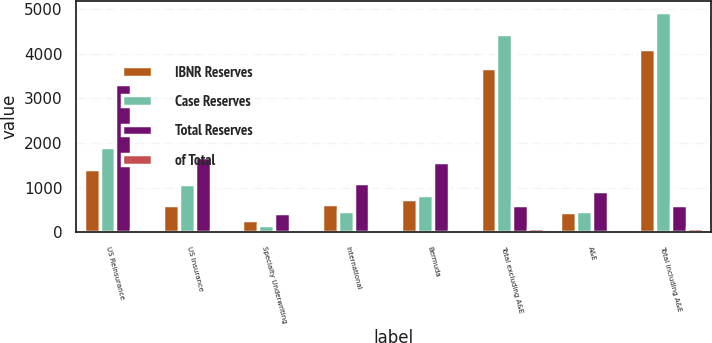Convert chart to OTSL. <chart><loc_0><loc_0><loc_500><loc_500><stacked_bar_chart><ecel><fcel>US Reinsurance<fcel>US Insurance<fcel>Specialty Underwriting<fcel>International<fcel>Bermuda<fcel>Total excluding A&E<fcel>A&E<fcel>Total including A&E<nl><fcel>IBNR Reserves<fcel>1414.2<fcel>597.5<fcel>273.2<fcel>632<fcel>753.1<fcel>3670<fcel>439.8<fcel>4109.8<nl><fcel>Case Reserves<fcel>1907<fcel>1083.7<fcel>161.3<fcel>472.8<fcel>823<fcel>4447.8<fcel>483<fcel>4930.8<nl><fcel>Total Reserves<fcel>3321.2<fcel>1681.2<fcel>434.5<fcel>1104.8<fcel>1576.1<fcel>614.75<fcel>922.8<fcel>614.75<nl><fcel>of Total<fcel>36.8<fcel>18.6<fcel>4.8<fcel>12.2<fcel>17.4<fcel>89.8<fcel>10.2<fcel>100<nl></chart> 